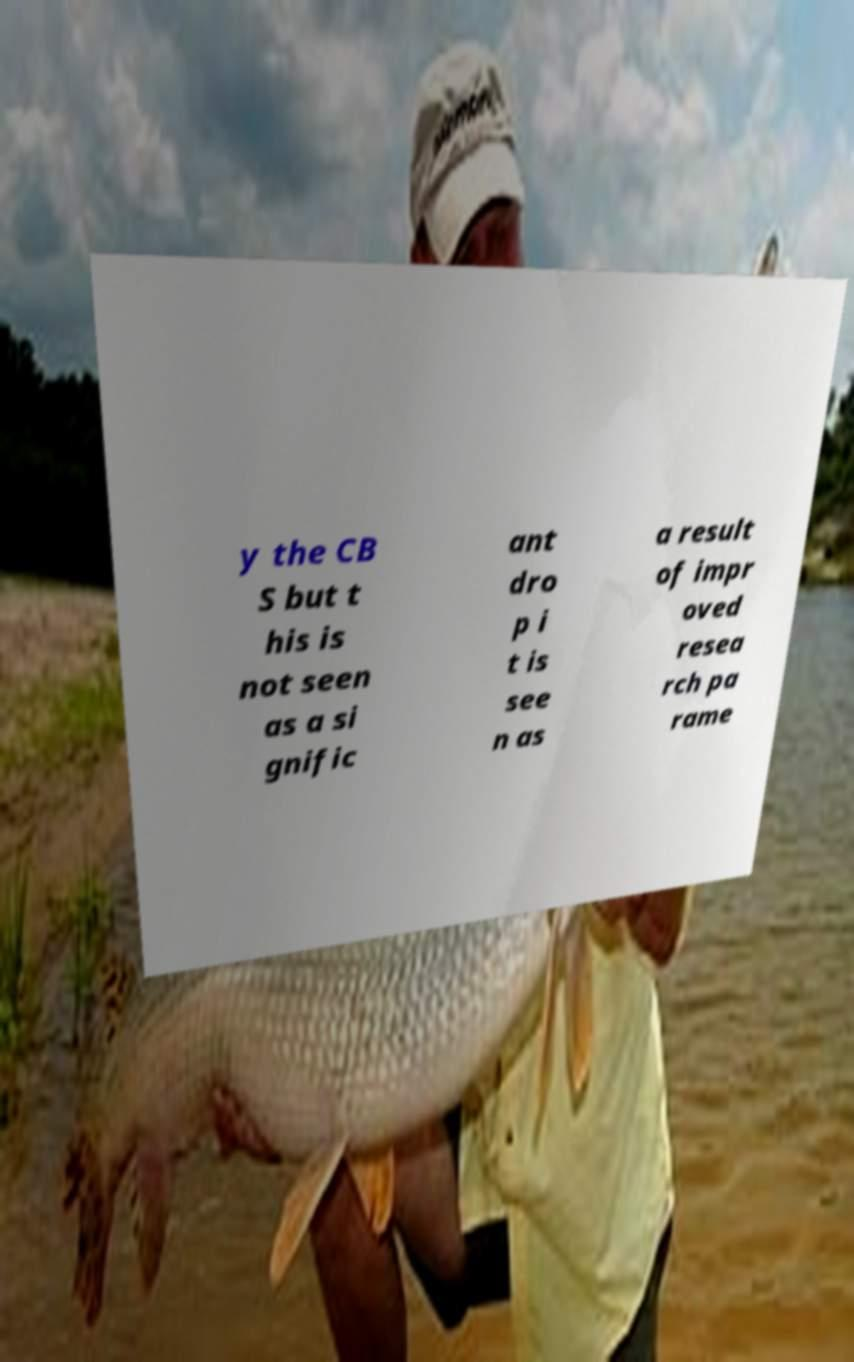There's text embedded in this image that I need extracted. Can you transcribe it verbatim? y the CB S but t his is not seen as a si gnific ant dro p i t is see n as a result of impr oved resea rch pa rame 